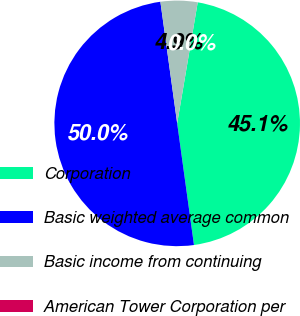Convert chart to OTSL. <chart><loc_0><loc_0><loc_500><loc_500><pie_chart><fcel>Corporation<fcel>Basic weighted average common<fcel>Basic income from continuing<fcel>American Tower Corporation per<nl><fcel>45.14%<fcel>50.0%<fcel>4.86%<fcel>0.0%<nl></chart> 